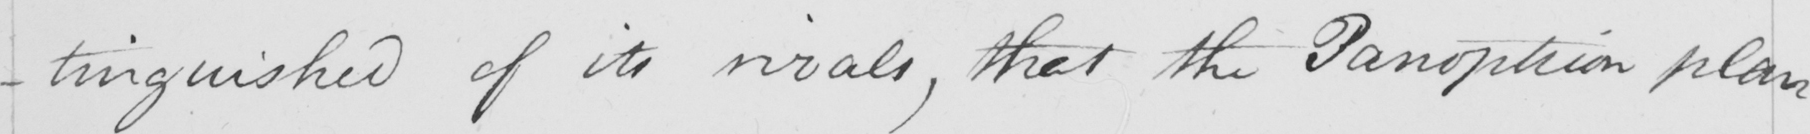Please transcribe the handwritten text in this image. -tinguished of its rivals , that the Panopticon plan 